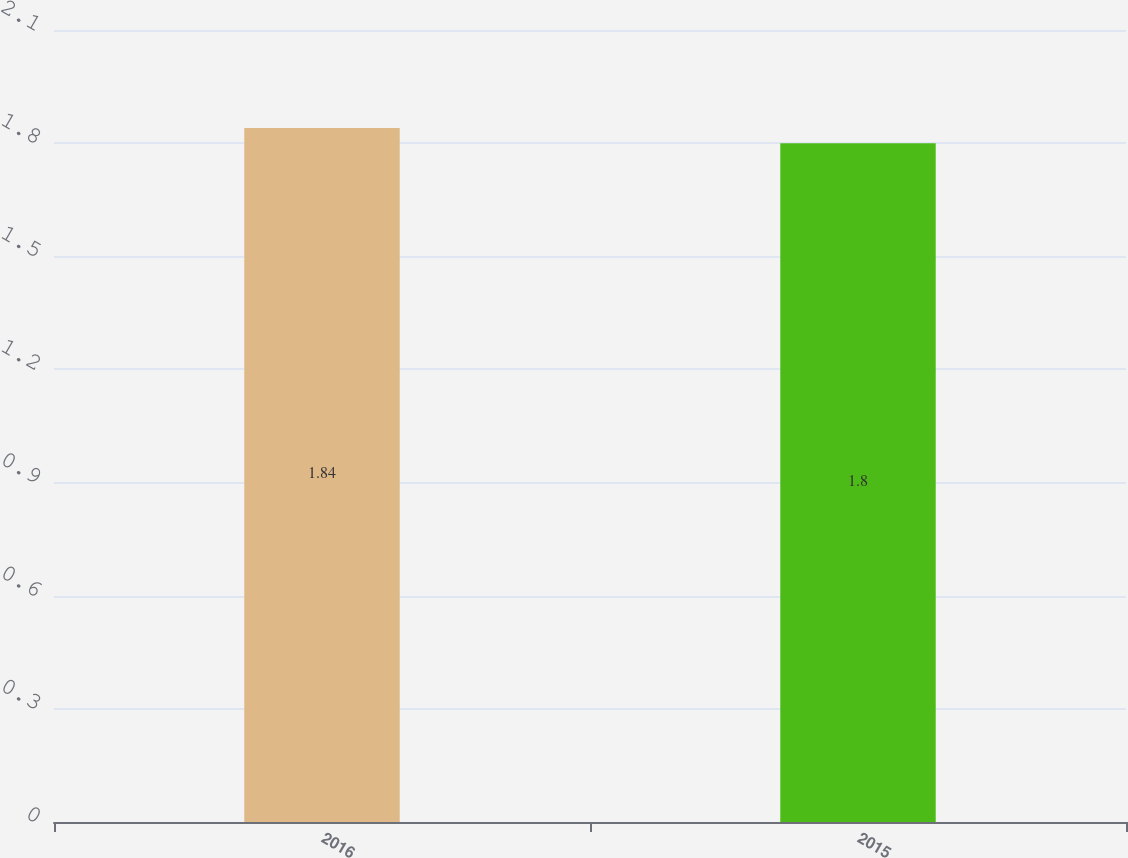Convert chart. <chart><loc_0><loc_0><loc_500><loc_500><bar_chart><fcel>2016<fcel>2015<nl><fcel>1.84<fcel>1.8<nl></chart> 